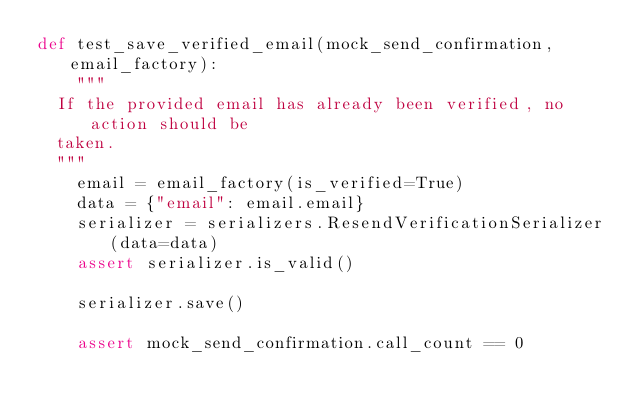Convert code to text. <code><loc_0><loc_0><loc_500><loc_500><_Python_>def test_save_verified_email(mock_send_confirmation, email_factory):
    """
	If the provided email has already been verified, no action should be
	taken.
	"""
    email = email_factory(is_verified=True)
    data = {"email": email.email}
    serializer = serializers.ResendVerificationSerializer(data=data)
    assert serializer.is_valid()

    serializer.save()

    assert mock_send_confirmation.call_count == 0
</code> 